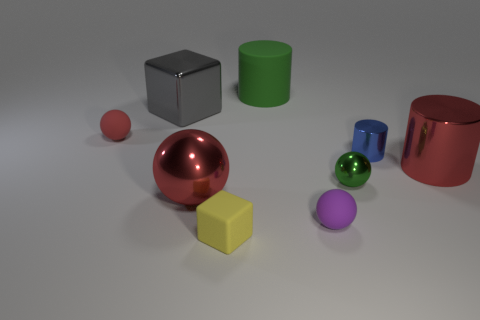Subtract all large cylinders. How many cylinders are left? 1 Add 1 green objects. How many objects exist? 10 Subtract all green cylinders. How many cylinders are left? 2 Subtract all balls. How many objects are left? 5 Subtract 1 cylinders. How many cylinders are left? 2 Add 7 yellow things. How many yellow things are left? 8 Add 6 red cylinders. How many red cylinders exist? 7 Subtract 0 gray cylinders. How many objects are left? 9 Subtract all yellow cubes. Subtract all brown balls. How many cubes are left? 1 Subtract all purple blocks. How many gray cylinders are left? 0 